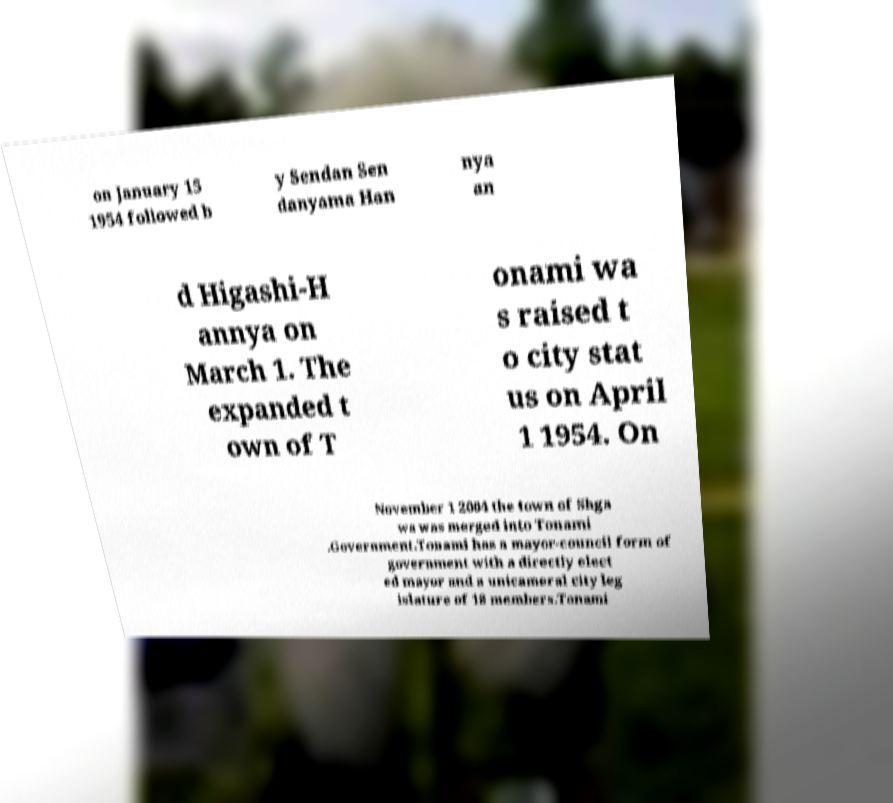Could you assist in decoding the text presented in this image and type it out clearly? on January 15 1954 followed b y Sendan Sen danyama Han nya an d Higashi-H annya on March 1. The expanded t own of T onami wa s raised t o city stat us on April 1 1954. On November 1 2004 the town of Shga wa was merged into Tonami .Government.Tonami has a mayor-council form of government with a directly elect ed mayor and a unicameral city leg islature of 18 members.Tonami 